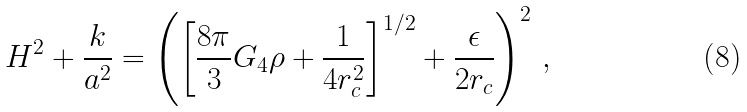<formula> <loc_0><loc_0><loc_500><loc_500>H ^ { 2 } + \frac { k } { a ^ { 2 } } = \left ( \left [ \frac { 8 \pi } { 3 } G _ { 4 } \rho + \frac { 1 } { 4 r _ { c } ^ { 2 } } \right ] ^ { 1 / 2 } + \frac { \epsilon } { 2 r _ { c } } \right ) ^ { 2 } \, ,</formula> 